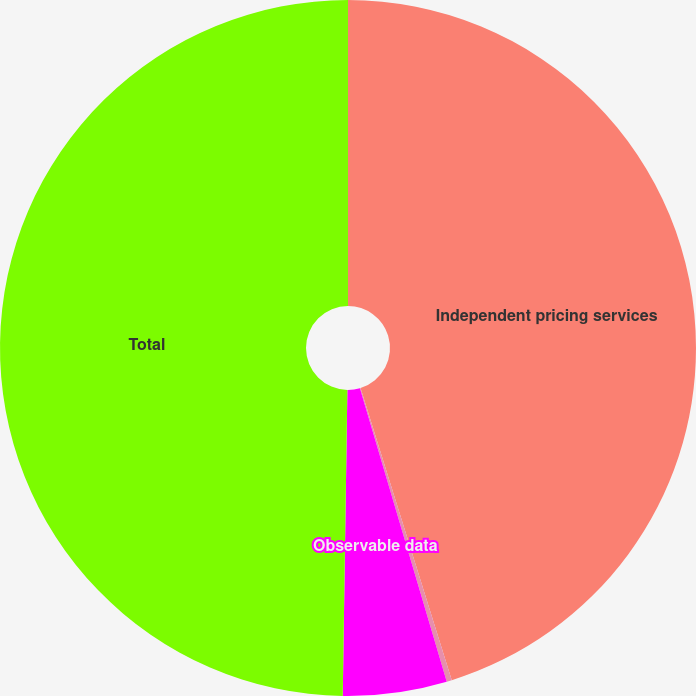Convert chart. <chart><loc_0><loc_0><loc_500><loc_500><pie_chart><fcel>Independent pricing services<fcel>Syndicate manager<fcel>Observable data<fcel>Total<nl><fcel>45.18%<fcel>0.24%<fcel>4.82%<fcel>49.76%<nl></chart> 